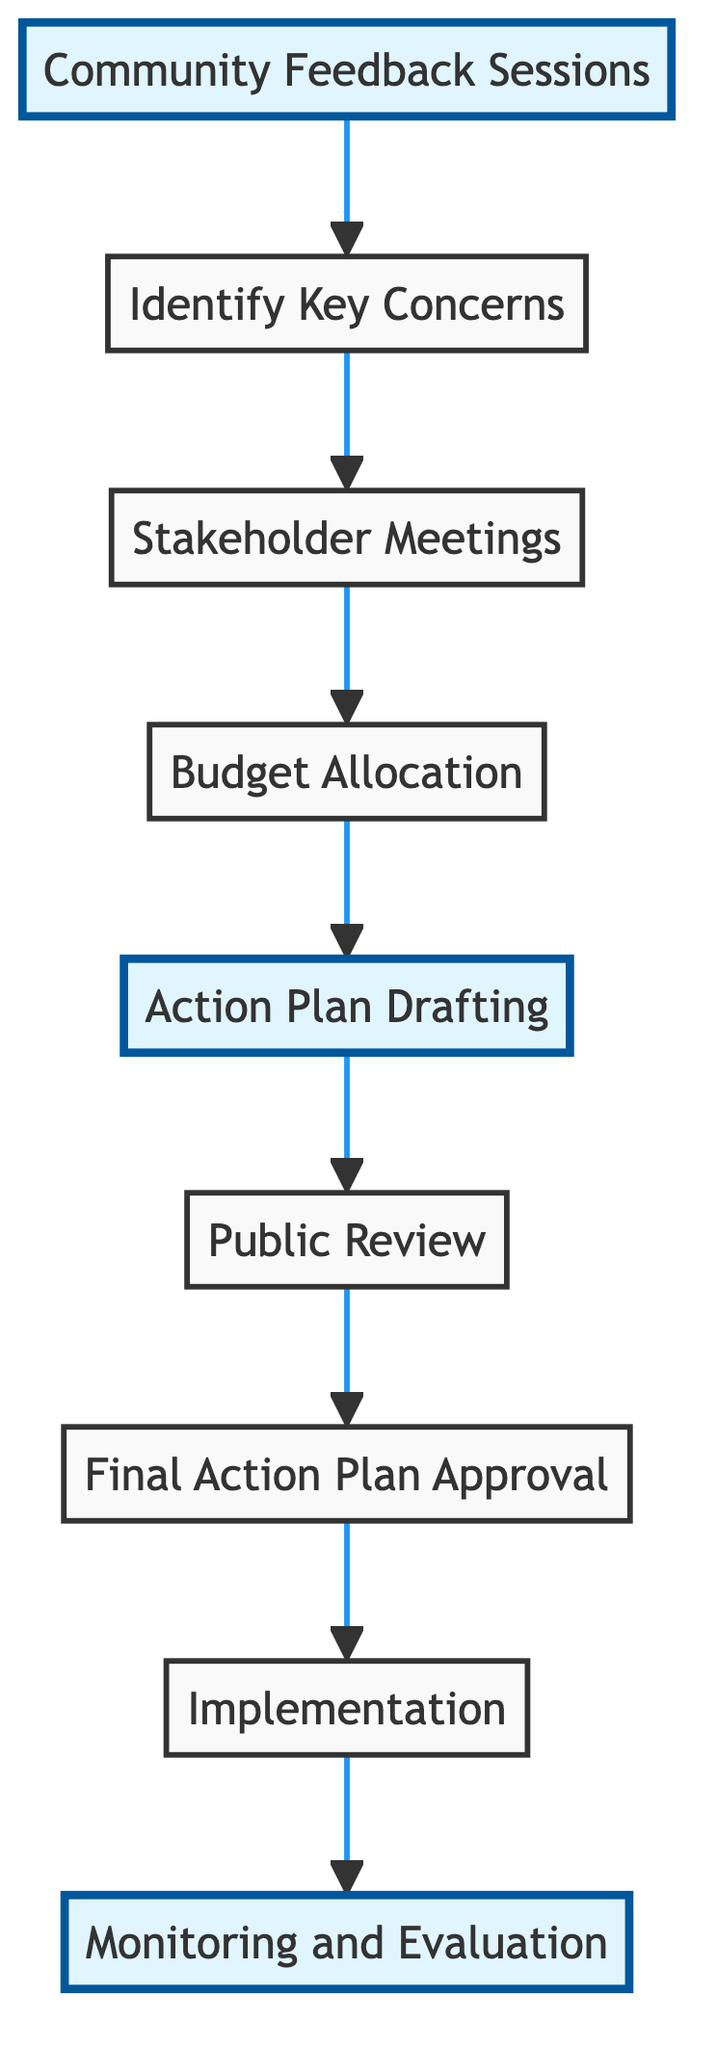What is the first step in the flowchart? The first step in the flowchart is "Community Feedback Sessions," which is the starting point of the process where input is gathered from residents and community activists.
Answer: Community Feedback Sessions How many nodes are present in the diagram? The diagram contains a total of nine nodes, representing different stages in the process of maintaining green spaces.
Answer: Nine Which node comes directly after "Budget Allocation"? The node that comes directly after "Budget Allocation" is "Action Plan Drafting," indicating that after budgeting, the next action is to draft a plan.
Answer: Action Plan Drafting What is the last step in the flowchart? The last step in the flowchart is "Monitoring and Evaluation," which signifies the conclusion of the implementation phase and involves ongoing assessment of the results.
Answer: Monitoring and Evaluation What entities are involved in the "Stakeholder Meetings"? The entities involved in "Stakeholder Meetings" are "Park Management," "Local Government," and "Community Leaders," as they discuss the identified concerns.
Answer: Park Management, Local Government, Community Leaders How many steps are there before the "Final Action Plan Approval"? There are five steps before the "Final Action Plan Approval," which include the initial steps leading to the formulation and public review of the action plan.
Answer: Five What is the relationship between "Public Review" and "Final Action Plan Approval"? The relationship is that "Public Review" leads to "Final Action Plan Approval"; feedback from the public is incorporated before approval.
Answer: Public Review leads to Final Action Plan Approval Which step focuses on executing the approved plans? The step that focuses on executing the approved plans is "Implementation," where the action plan is put into practice.
Answer: Implementation What is the role of "Quality Control Teams" in the last step? "Quality Control Teams" play a key role in "Monitoring and Evaluation," as they ensure the maintenance efforts are effective and provide assessments.
Answer: Monitoring and Evaluation 